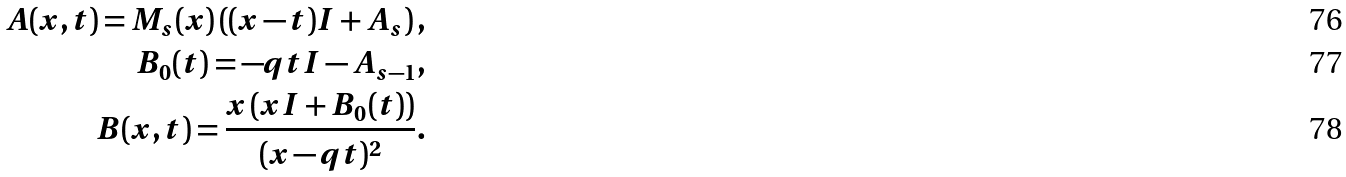<formula> <loc_0><loc_0><loc_500><loc_500>A ( x , t ) = M _ { s } ( x ) \left ( ( x - t ) I + A _ { s } \right ) , \\ B _ { 0 } ( t ) = - q t I - A _ { s - 1 } , \\ B ( x , t ) = \frac { x \left ( x I + B _ { 0 } ( t ) \right ) } { ( x - q t ) ^ { 2 } } .</formula> 